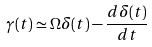Convert formula to latex. <formula><loc_0><loc_0><loc_500><loc_500>\gamma ( t ) \simeq \Omega \delta ( t ) - \frac { d \delta ( t ) } { d t }</formula> 